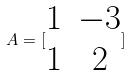Convert formula to latex. <formula><loc_0><loc_0><loc_500><loc_500>A = [ \begin{matrix} 1 & - 3 \\ 1 & 2 \end{matrix} ]</formula> 